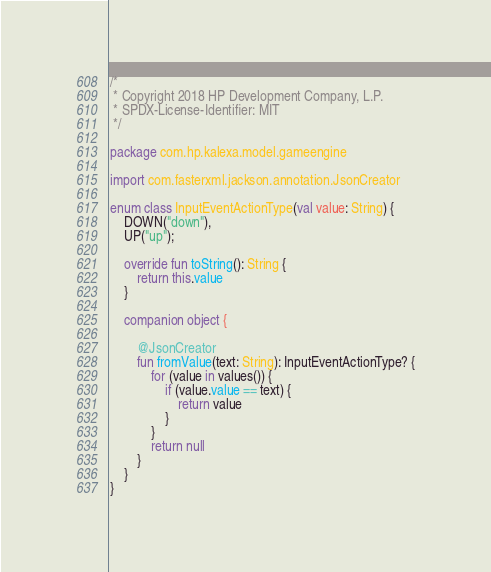<code> <loc_0><loc_0><loc_500><loc_500><_Kotlin_>/*
 * Copyright 2018 HP Development Company, L.P.
 * SPDX-License-Identifier: MIT
 */

package com.hp.kalexa.model.gameengine

import com.fasterxml.jackson.annotation.JsonCreator

enum class InputEventActionType(val value: String) {
    DOWN("down"),
    UP("up");

    override fun toString(): String {
        return this.value
    }

    companion object {

        @JsonCreator
        fun fromValue(text: String): InputEventActionType? {
            for (value in values()) {
                if (value.value == text) {
                    return value
                }
            }
            return null
        }
    }
}
</code> 